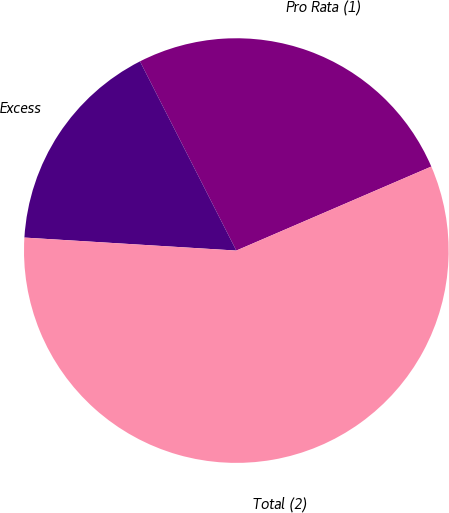Convert chart to OTSL. <chart><loc_0><loc_0><loc_500><loc_500><pie_chart><fcel>Pro Rata (1)<fcel>Excess<fcel>Total (2)<nl><fcel>26.02%<fcel>16.53%<fcel>57.45%<nl></chart> 